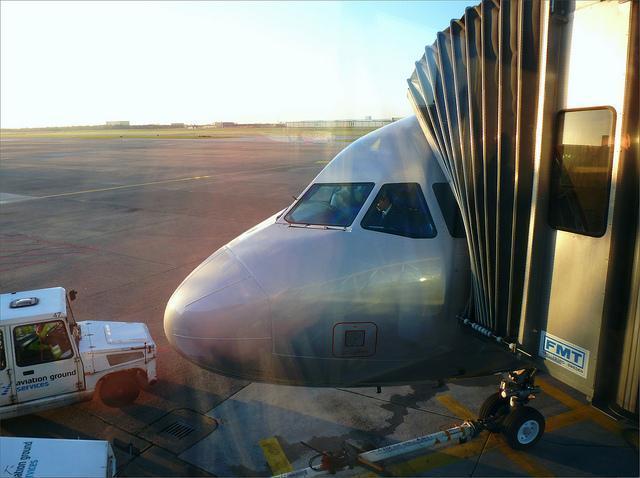How many giraffes are there in the grass?
Give a very brief answer. 0. 